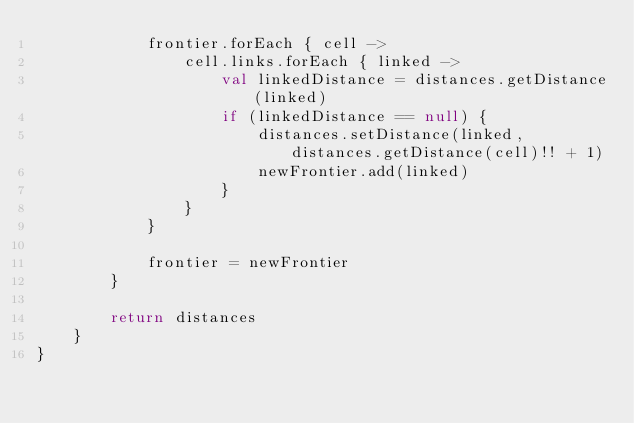Convert code to text. <code><loc_0><loc_0><loc_500><loc_500><_Kotlin_>            frontier.forEach { cell ->
                cell.links.forEach { linked ->
                    val linkedDistance = distances.getDistance(linked)
                    if (linkedDistance == null) {
                        distances.setDistance(linked, distances.getDistance(cell)!! + 1)
                        newFrontier.add(linked)
                    }
                }
            }

            frontier = newFrontier
        }

        return distances
    }
}
</code> 